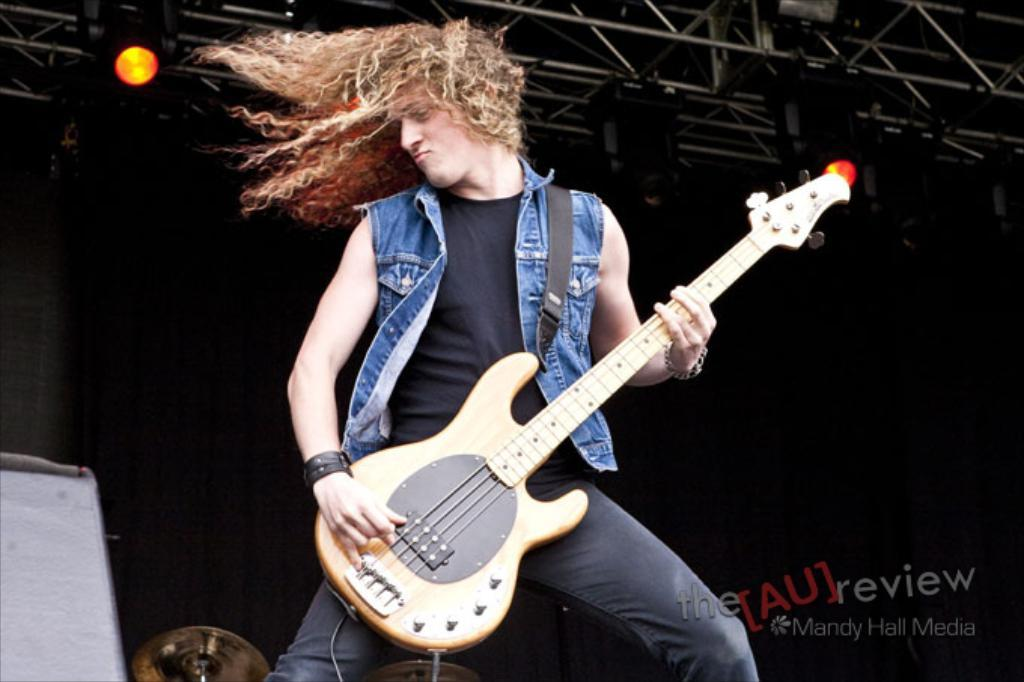What is the overall color scheme of the background in the image? The background of the picture is dark. Can you identify any light source in the image? Yes, there is a light in the image. What is the person in the image doing? The person is standing and playing a guitar. How would you describe the person's hair in the image? The person has long and curly hair. What other musical instrument can be seen in the image? There is a cymbal in the image. What type of learning is taking place in the office depicted in the image? There is no office or learning depicted in the image; it features a person playing a guitar with a dark background and a light source. How does the person's breath affect the sound of the guitar in the image? The image does not show the person's breath or any indication of how it might affect the sound of the guitar. 